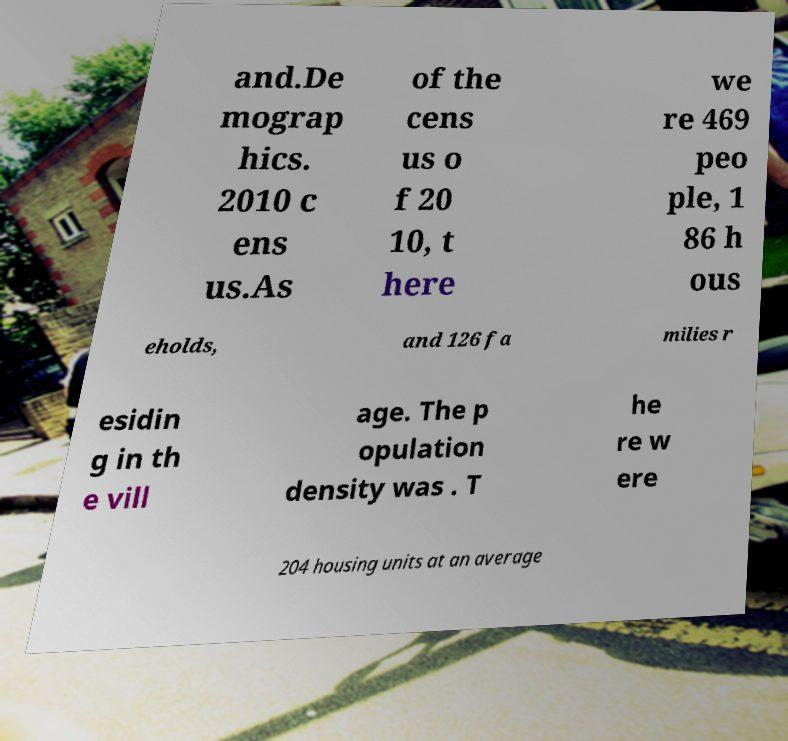For documentation purposes, I need the text within this image transcribed. Could you provide that? and.De mograp hics. 2010 c ens us.As of the cens us o f 20 10, t here we re 469 peo ple, 1 86 h ous eholds, and 126 fa milies r esidin g in th e vill age. The p opulation density was . T he re w ere 204 housing units at an average 